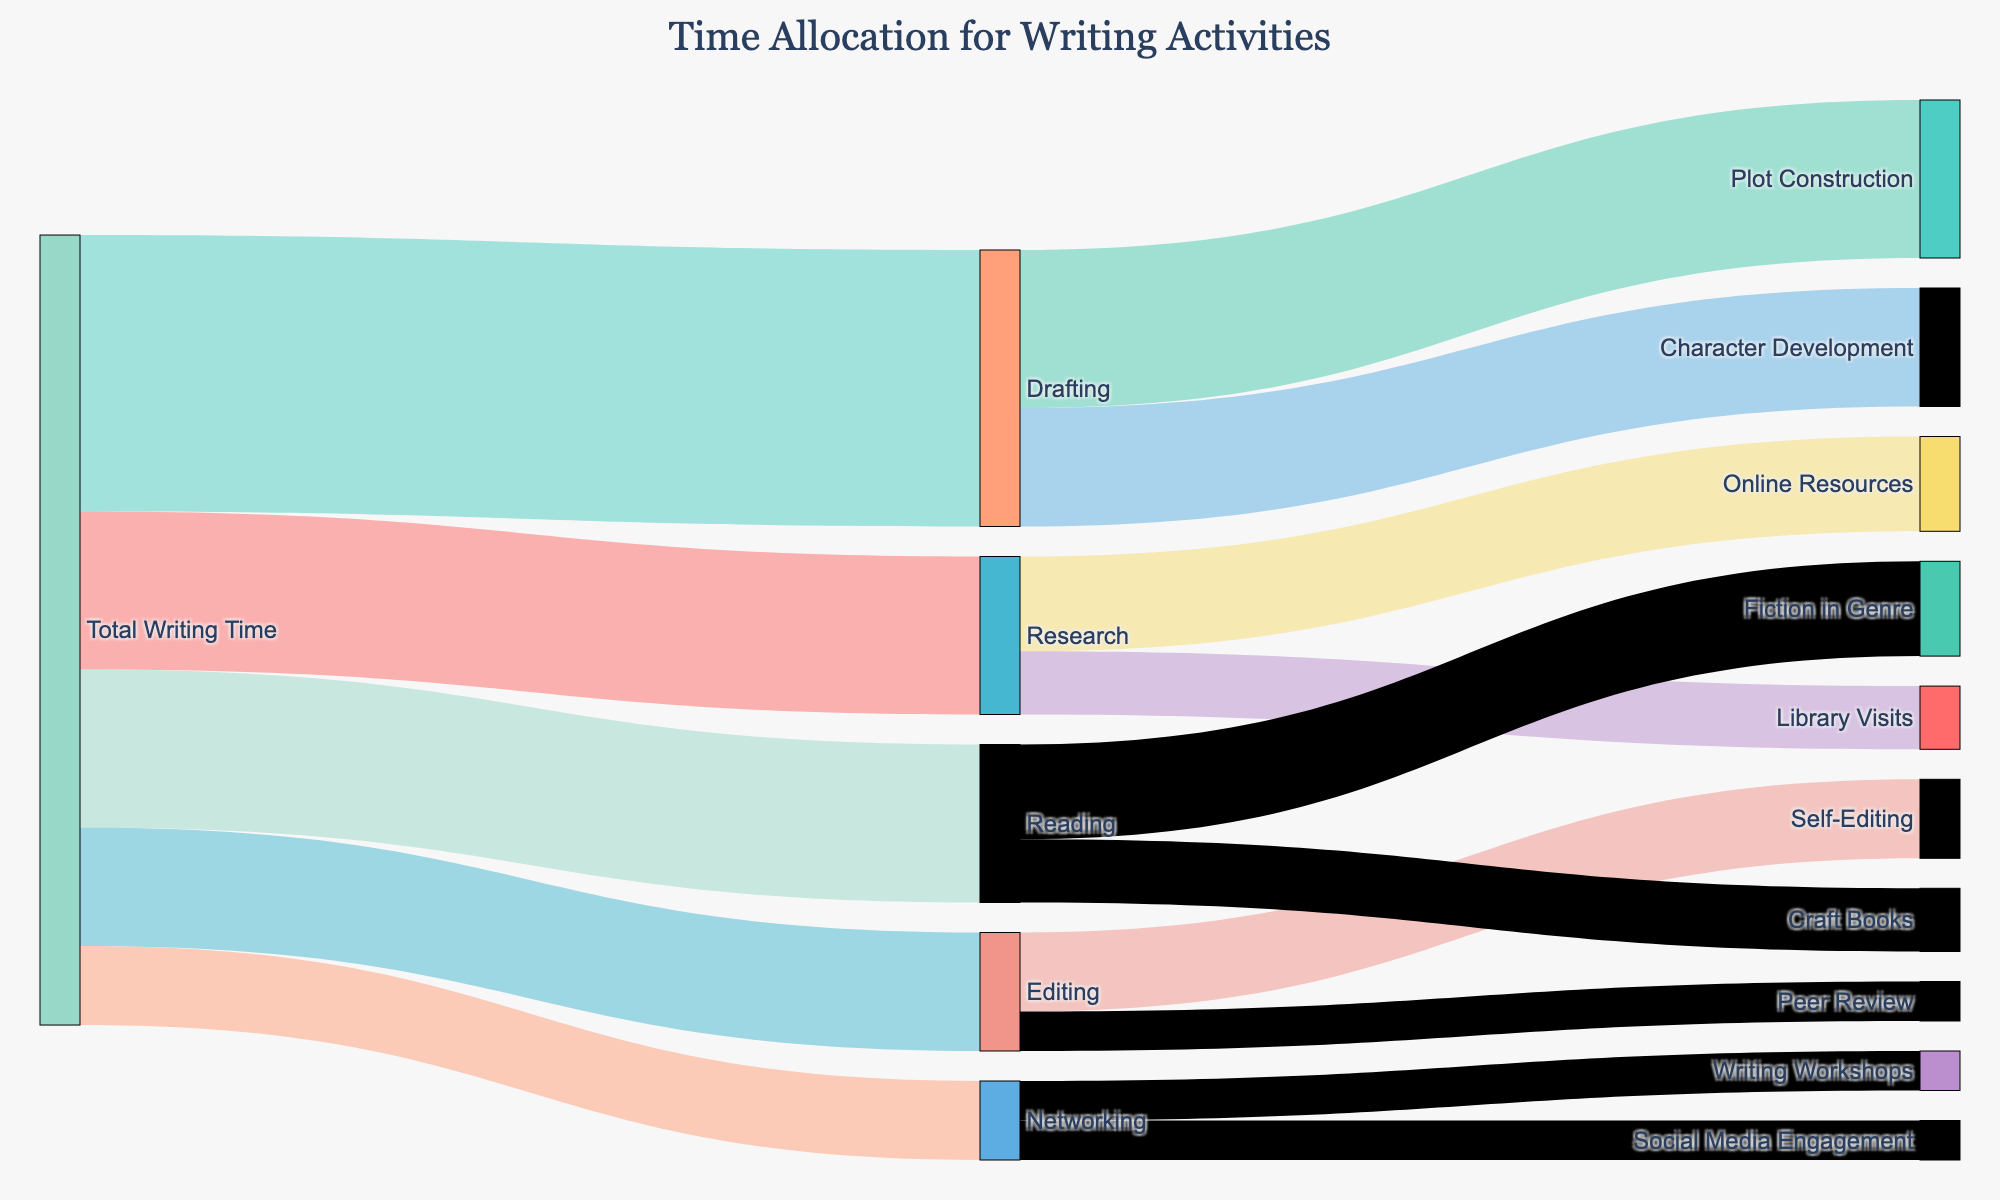How much time is devoted to Drafting? Add up the time allocated to Character Development and Plot Construction, both under Drafting: 15 (Character Development) + 20 (Plot Construction).
Answer: 35 Which activity under Research takes the most time? Compare Online Resources and Library Visits. Online Resources is 12, Library Visits is 8. Online Resources is higher.
Answer: Online Resources What's the total time dedicated to Reading? Sum up the time allocated to Fiction in Genre and Craft Books: 12 (Fiction in Genre) + 8 (Craft Books).
Answer: 20 How much more time is spent on Drafting compared to Editing? Subtract the time spent on Editing from Drafting: 35 (Drafting) - 15 (Editing).
Answer: 20 Which has a higher allocation: Networking or Reading? Compare the total time for Networking (10) and Reading (20). Reading is higher.
Answer: Reading What is the smallest time allocation among all categories and sub-categories? Compare all values: Online Resources (12), Library Visits (8), Character Development (15), Plot Construction (20), Self-Editing (10), Peer Review (5), Writing Workshops (5), Social Media Engagement (5), Fiction in Genre (12), Craft Books (8). Peer Review, Writing Workshops, and Social Media Engagement are all the smallest, each at 5.
Answer: 5 Which activity under Networking takes the same amount of time as Peer Review? Compare times under Networking: Writing Workshops (5), Social Media Engagement (5). Both are equal to Peer Review (5).
Answer: Writing Workshops, Social Media Engagement What's the ratio of time spent on Fiction in Genre to Craft Books? Divide the time spent on Fiction in Genre by the time spent on Craft Books: 12 (Fiction in Genre) / 8 (Craft Books).
Answer: 1.5 If the time for Library Visits is increased by 50%, how much is it? Increase 8 (Library Visits) by 50%: 8 + (8 * 0.5) = 8 + 4 = 12.
Answer: 12 